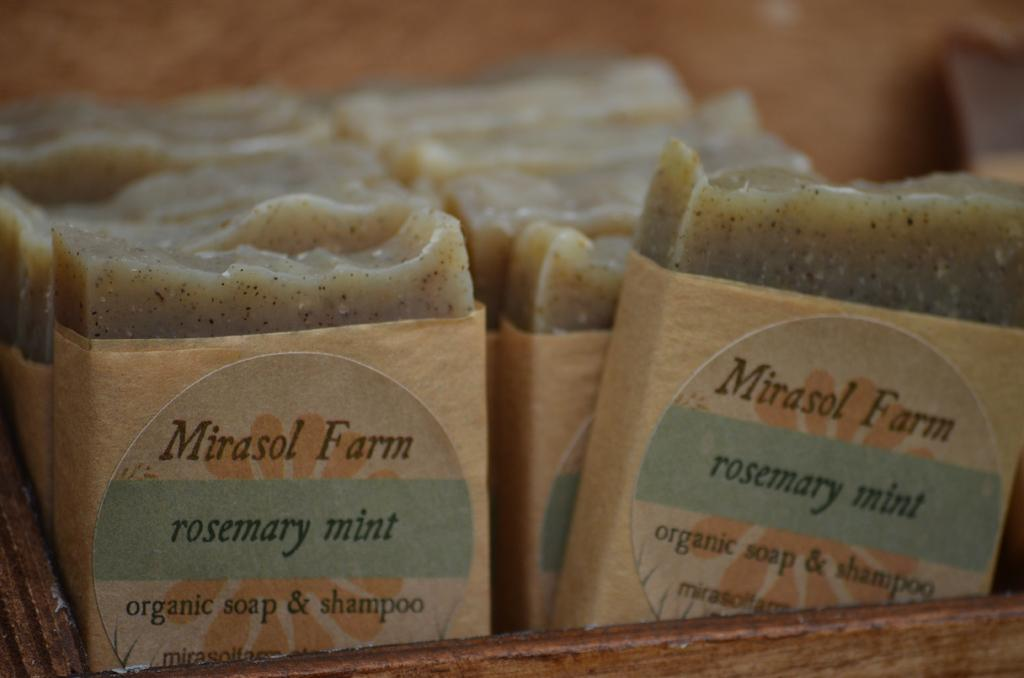What types of items are in the image? The image contains food items. How are the food items arranged or presented? The food items are packed and placed in a box. How many cats can be seen in the image? There are no cats present in the image. What type of shellfish is visible in the image? There is no shellfish, such as a clam, present in the image. 